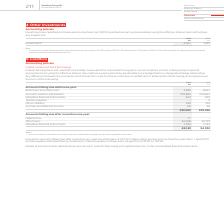From Vodafone Group Plc's financial document, What financial items does amounts falling due within one year consist of? The document contains multiple relevant values: Bank loans and other loans, Amounts owed to subsidiaries, Derivative financial instruments, Taxation payable, Other creditors, Accruals and deferred income. From the document: "229 Taxation payable – 9 Other creditors 945 120 Accruals and deferred income 66 46 239,205 229,396 67 Amounts owed to subsidiaries 1 232,896 220,625 ..." Also, What financial items does amounts falling due after more than one year consist of? The document contains multiple relevant values: Deferred tax, Other loans, Derivative financial instruments. From the document: "Amounts falling due after more than one year: Deferred tax 17 – Other loans 46,208 32,199 Derivative financial instruments 1,924 2,133 48,149 34,332 o..." Also, can you calculate: What is the 2019 average total amount falling due within one year ? To answer this question, I need to perform calculations using the financial data. The calculation is: (239,205+229,396)/2, which equals 234300.5 (in millions). This is based on the information: "45 120 Accruals and deferred income 66 46 239,205 229,396 ditors 945 120 Accruals and deferred income 66 46 239,205 229,396..." The key data points involved are: 229,396, 239,205. Also, What is the 2019 amounts owed to subsidiaries within one year? According to the financial document, 232,896 (in millions). The relevant text states: "loans 4,835 8,367 Amounts owed to subsidiaries 1 232,896 220,625 Derivative financial instruments 463 229 Taxation payable – 9 Other creditors 945 120 Accru..." Also, can you calculate: What is the 2019 average total amounts falling due after more than one year ? To answer this question, I need to perform calculations using the financial data. The calculation is: (48,149+34,332)/2, which equals 41240.5 (in millions). This is based on the information: "rivative financial instruments 1,924 2,133 48,149 34,332 ,199 Derivative financial instruments 1,924 2,133 48,149 34,332..." The key data points involved are: 34,332, 48,149. Additionally, Which year has a higher amount of bank loans and other loans under amounts falling due within one year? According to the financial document, 2018. The relevant text states: "2019 2018 €m €m Investments 1 2,301 1,945..." 